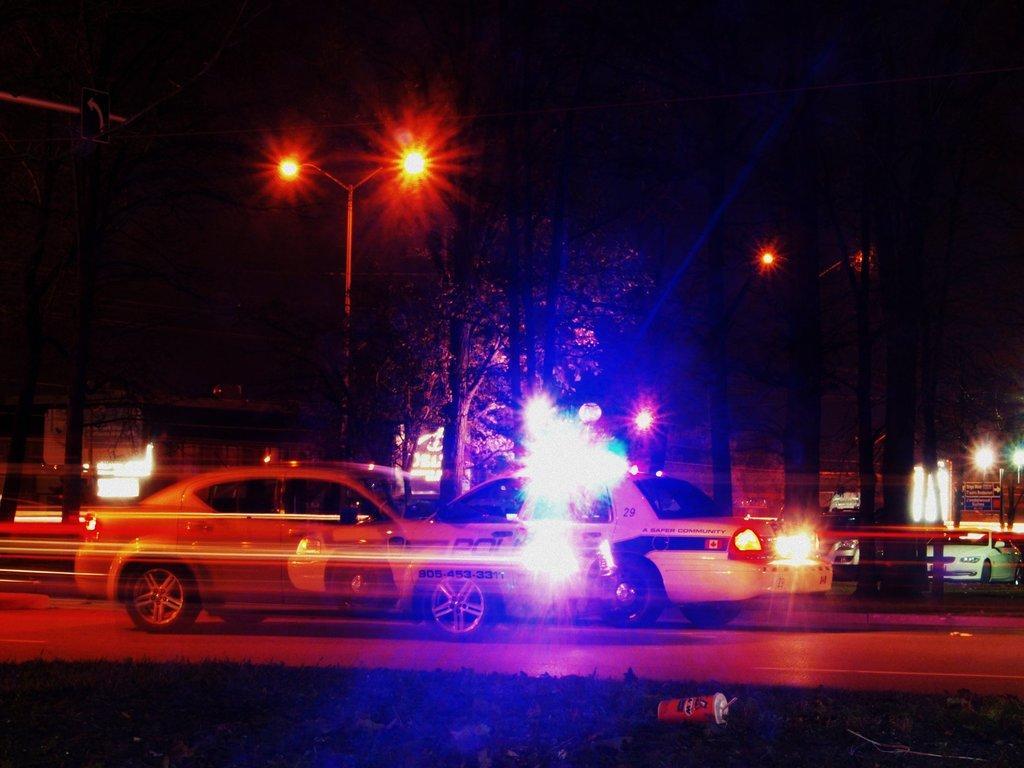Can you describe this image briefly? In this image we can see few vehicles. There are few street lights in the image. There is a grassy land at the bottom of the image. We can see a container on the ground at the bottom of the image. We can see many trees in the image. There is a board at the left side of the image. 